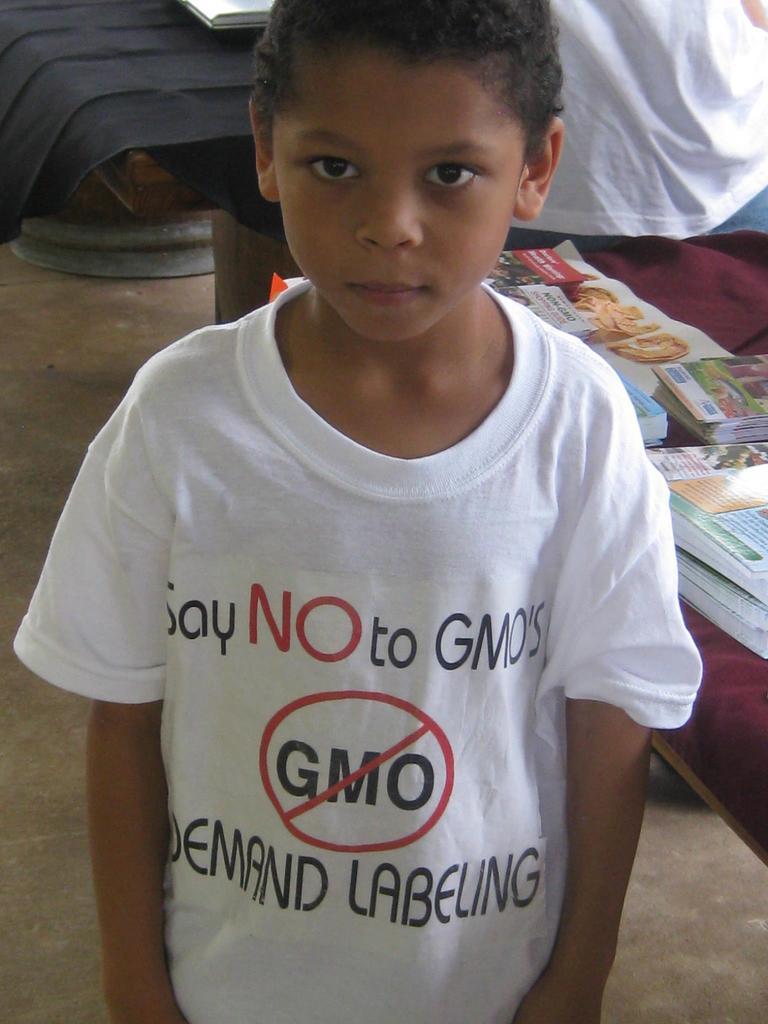Describe this image in one or two sentences. In this picture we can see a boy and in the background we can see some books. 